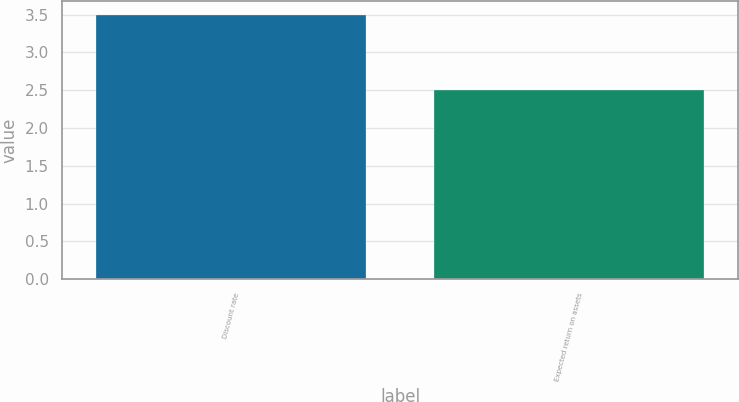Convert chart to OTSL. <chart><loc_0><loc_0><loc_500><loc_500><bar_chart><fcel>Discount rate<fcel>Expected return on assets<nl><fcel>3.5<fcel>2.5<nl></chart> 